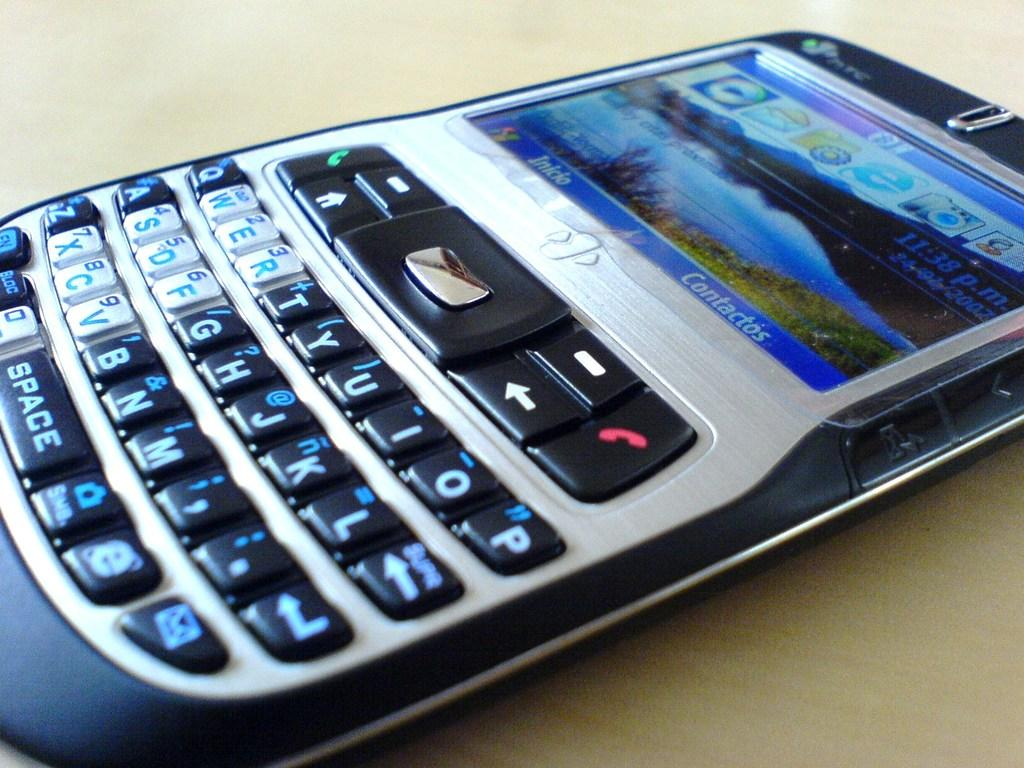<image>
Summarize the visual content of the image. A blackberry phone that has "Contactos" and "Inicio" printed in Spanish on the screen. 